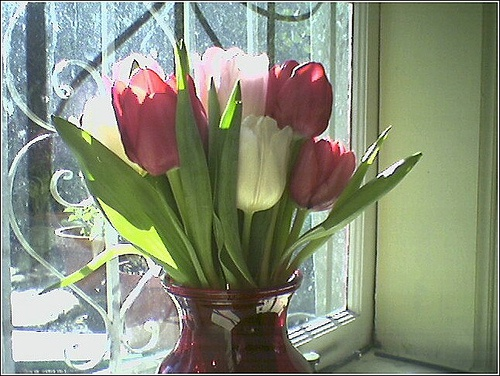Describe the objects in this image and their specific colors. I can see vase in black, maroon, and gray tones, potted plant in black, beige, darkgray, khaki, and olive tones, and potted plant in black, darkgray, lightgray, and gray tones in this image. 